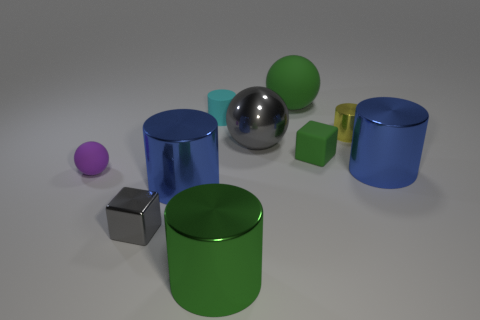Does the metal cube have the same color as the shiny sphere?
Ensure brevity in your answer.  Yes. The metallic object that is the same color as the large matte object is what size?
Provide a short and direct response. Large. There is a rubber block; are there any big green things to the right of it?
Provide a short and direct response. No. What is the shape of the yellow metallic thing?
Your answer should be compact. Cylinder. What number of things are small blocks that are to the right of the big green rubber thing or large brown matte things?
Offer a terse response. 1. What number of other objects are there of the same color as the small metallic cylinder?
Your answer should be very brief. 0. There is a big rubber thing; is it the same color as the tiny metal thing that is in front of the big gray sphere?
Offer a very short reply. No. What color is the other large rubber thing that is the same shape as the large gray thing?
Your answer should be very brief. Green. Are the green cylinder and the small block on the right side of the tiny gray metallic block made of the same material?
Provide a short and direct response. No. The tiny metal cylinder has what color?
Keep it short and to the point. Yellow. 